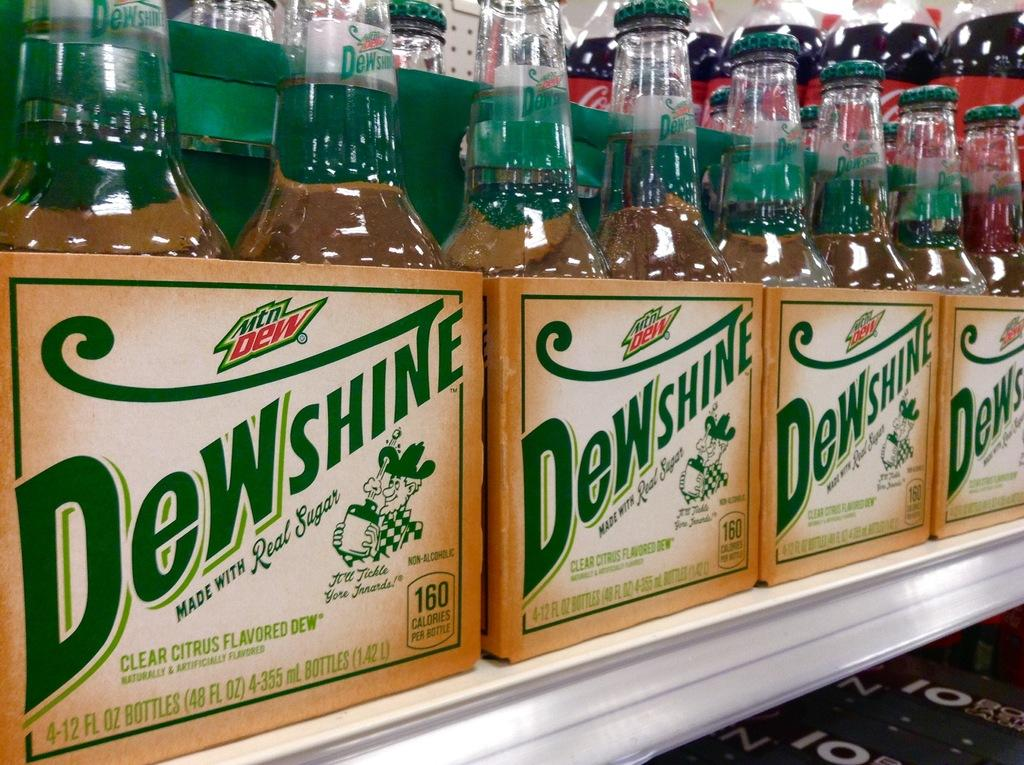<image>
Present a compact description of the photo's key features. Multiple packages of a clear citrus flavoured drink by a brand called Dewshine. 